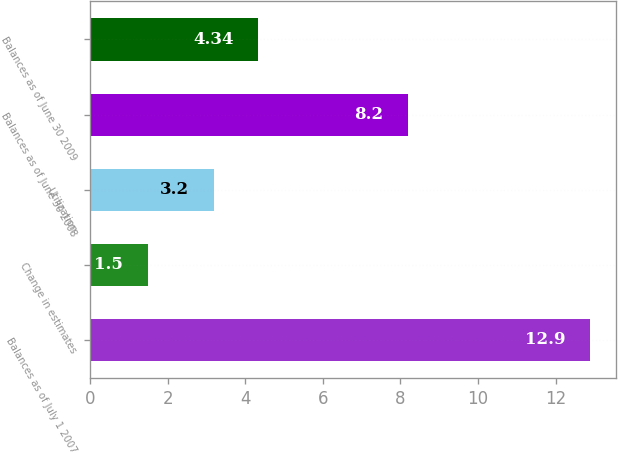Convert chart. <chart><loc_0><loc_0><loc_500><loc_500><bar_chart><fcel>Balances as of July 1 2007<fcel>Change in estimates<fcel>Utilization<fcel>Balances as of June 30 2008<fcel>Balances as of June 30 2009<nl><fcel>12.9<fcel>1.5<fcel>3.2<fcel>8.2<fcel>4.34<nl></chart> 